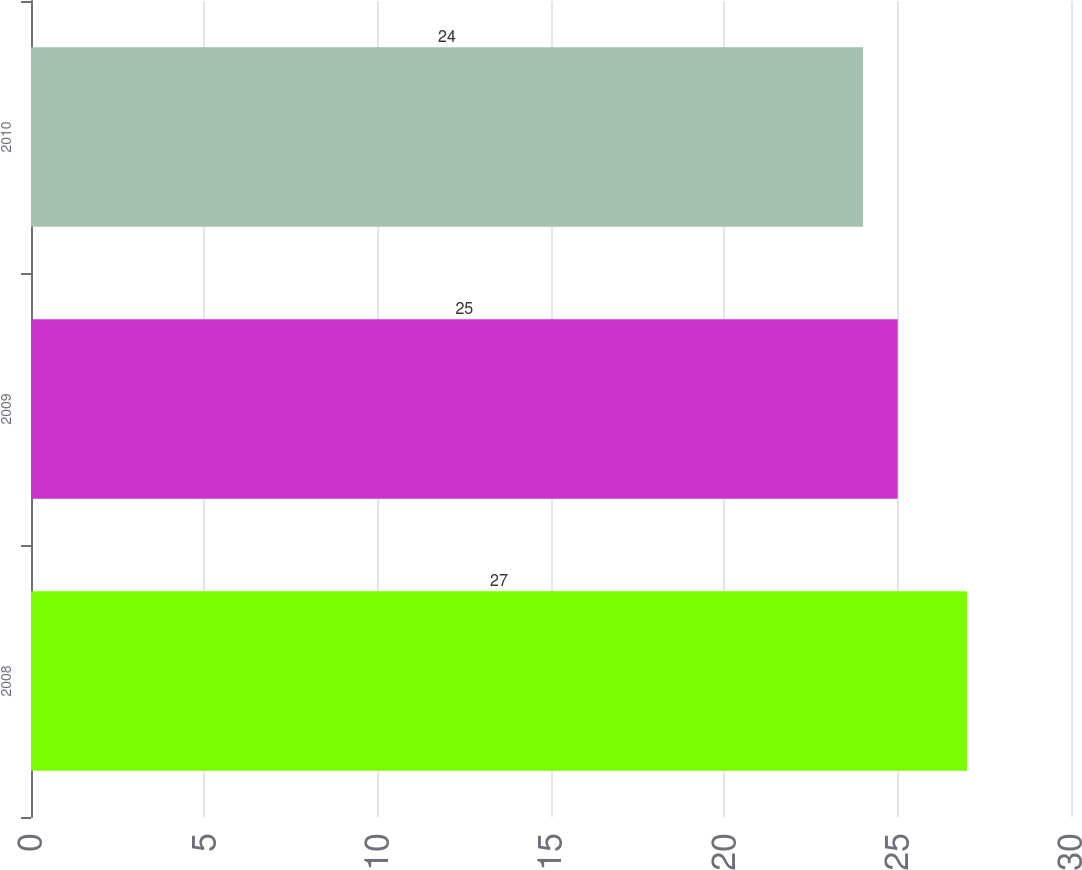Convert chart. <chart><loc_0><loc_0><loc_500><loc_500><bar_chart><fcel>2008<fcel>2009<fcel>2010<nl><fcel>27<fcel>25<fcel>24<nl></chart> 